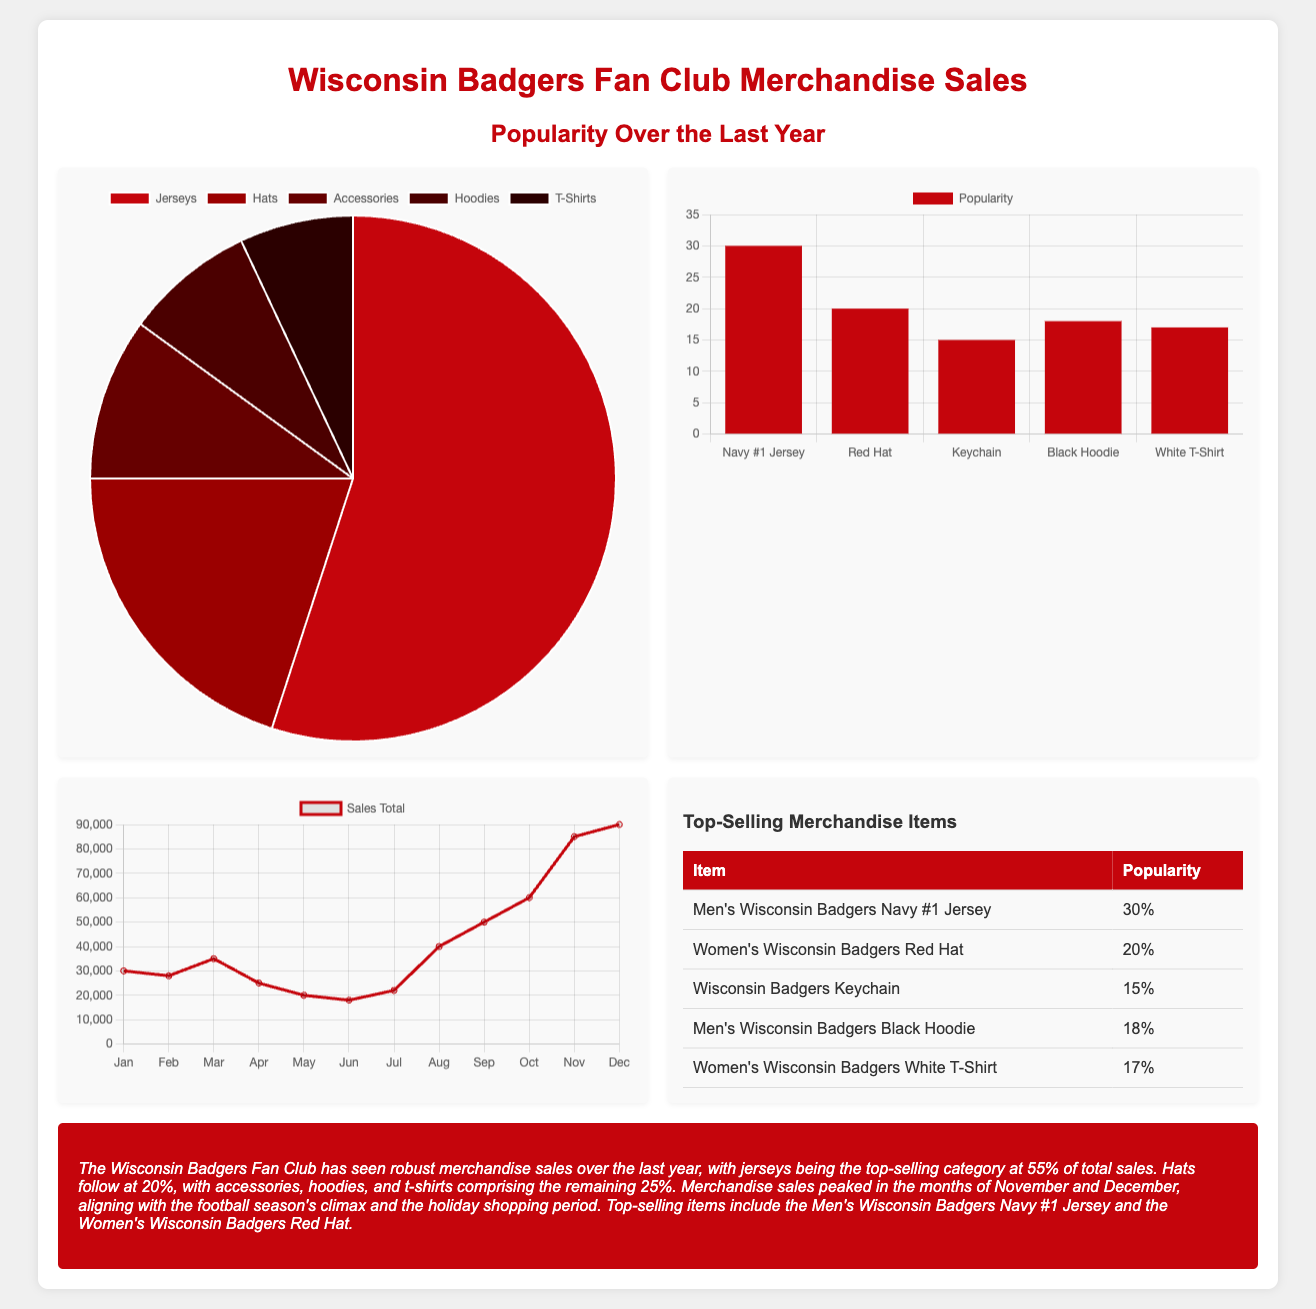What is the percentage of jersey sales? The document states that jerseys account for 55% of total sales.
Answer: 55% What item has the highest popularity? According to the table, the Men's Wisconsin Badgers Navy #1 Jersey has the highest popularity at 30%.
Answer: Men's Wisconsin Badgers Navy #1 Jersey What is the total sales amount in December? The Trends Chart shows that sales totaled $90,000 in December.
Answer: $90,000 What percentage of sales does the hats category represent? The document indicates hats represent 20% of total sales.
Answer: 20% Which month showed the lowest sales total? In the Trends Chart, June is the month that shows the lowest sales total at $18,000.
Answer: June What market trend is highlighted in the summary? The summary mentions that merchandise sales peaked in November and December.
Answer: Peak sales months Which merchandise category has the smallest percentage of sales? Accessories have the smallest percentage of sales at 10%.
Answer: 10% How many total items are listed in the top-selling merchandise table? There are five items listed in the table of top-selling merchandise.
Answer: Five items What color theme is used for the background of the merchandise sales charts? The charts have a white and red color theme, primarily featuring the color red.
Answer: Red and white 